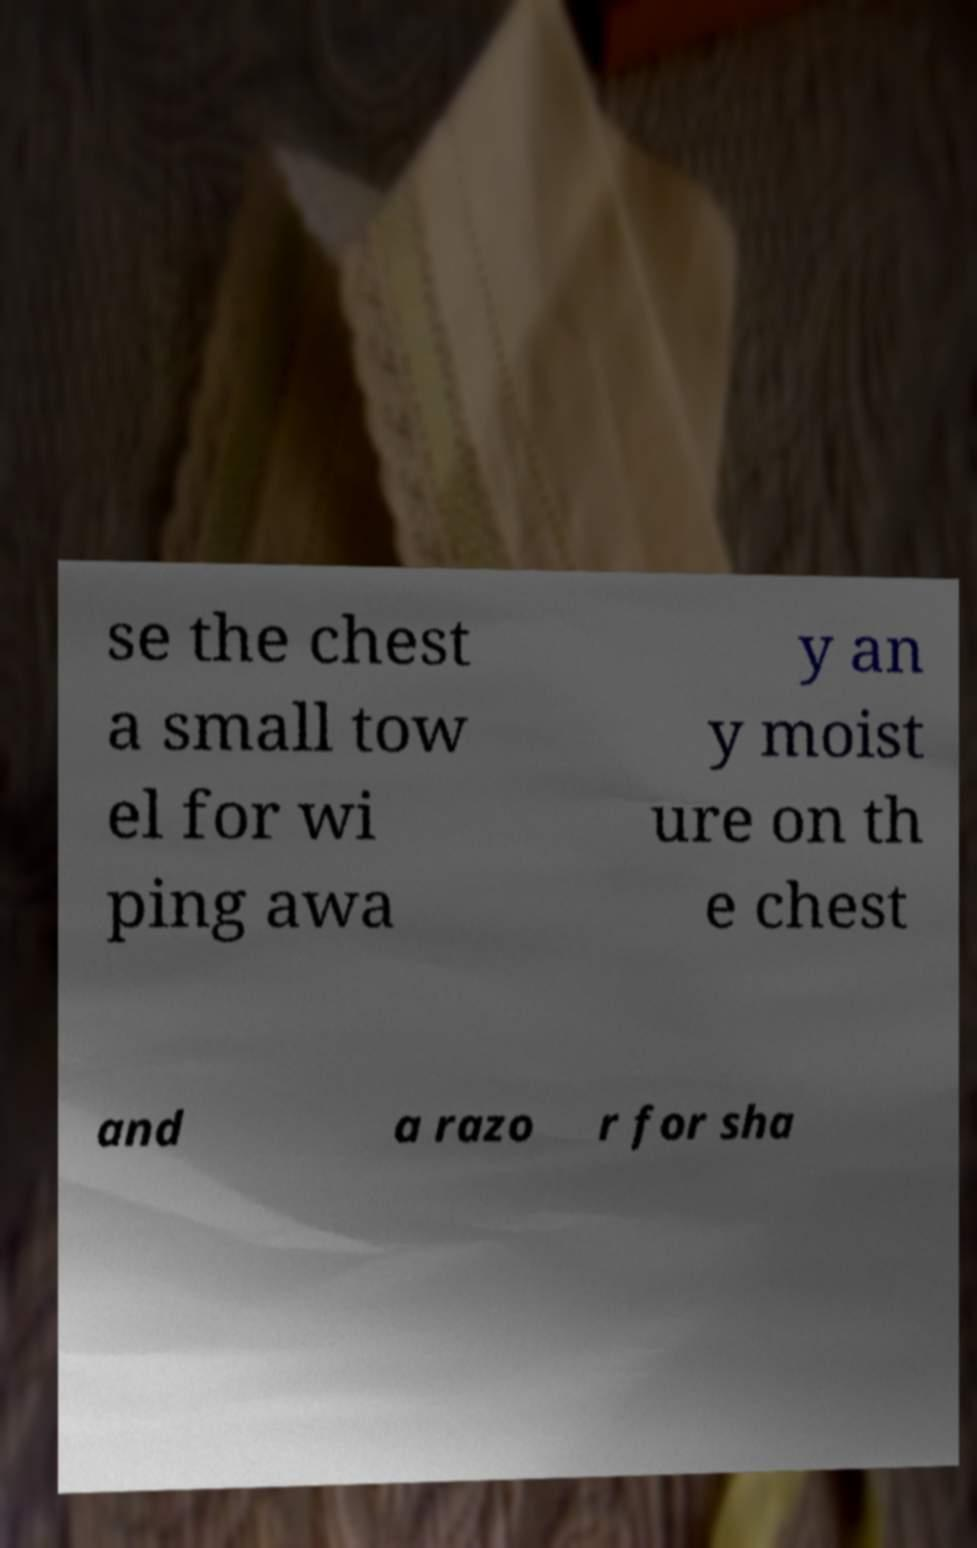Please identify and transcribe the text found in this image. se the chest a small tow el for wi ping awa y an y moist ure on th e chest and a razo r for sha 